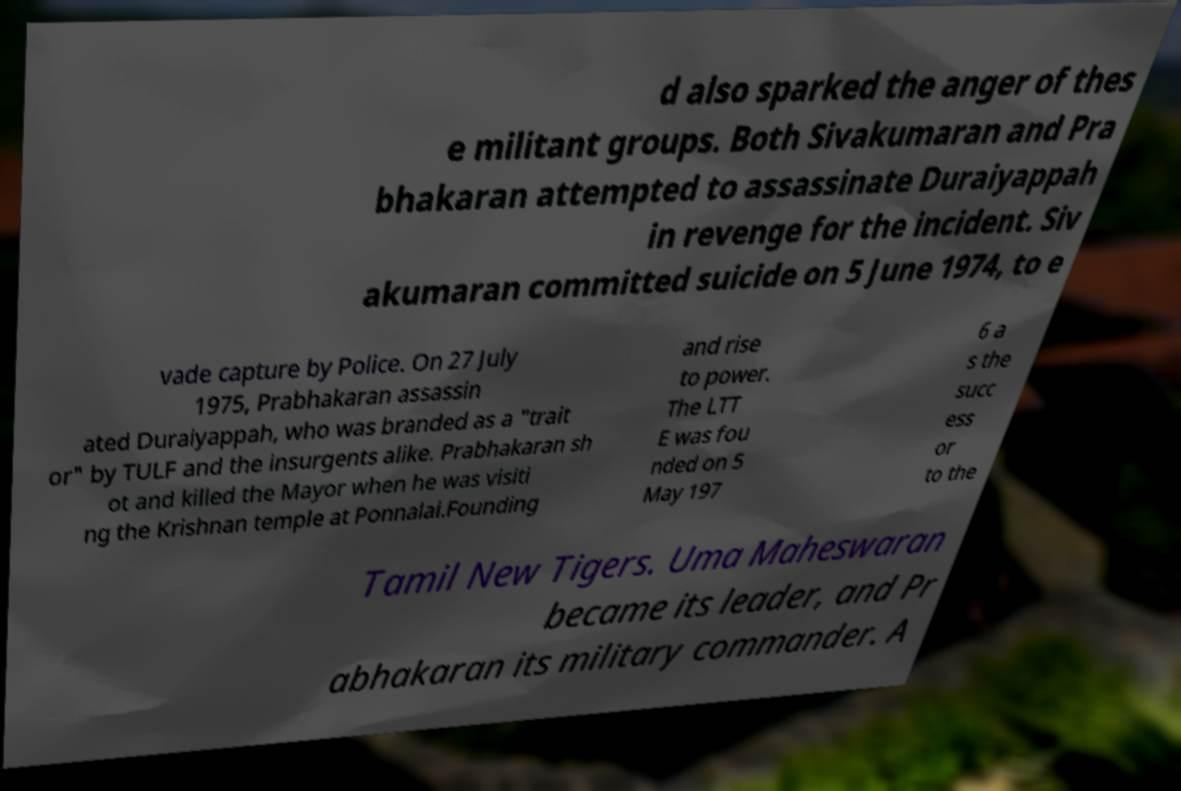Can you read and provide the text displayed in the image?This photo seems to have some interesting text. Can you extract and type it out for me? d also sparked the anger of thes e militant groups. Both Sivakumaran and Pra bhakaran attempted to assassinate Duraiyappah in revenge for the incident. Siv akumaran committed suicide on 5 June 1974, to e vade capture by Police. On 27 July 1975, Prabhakaran assassin ated Duraiyappah, who was branded as a "trait or" by TULF and the insurgents alike. Prabhakaran sh ot and killed the Mayor when he was visiti ng the Krishnan temple at Ponnalai.Founding and rise to power. The LTT E was fou nded on 5 May 197 6 a s the succ ess or to the Tamil New Tigers. Uma Maheswaran became its leader, and Pr abhakaran its military commander. A 